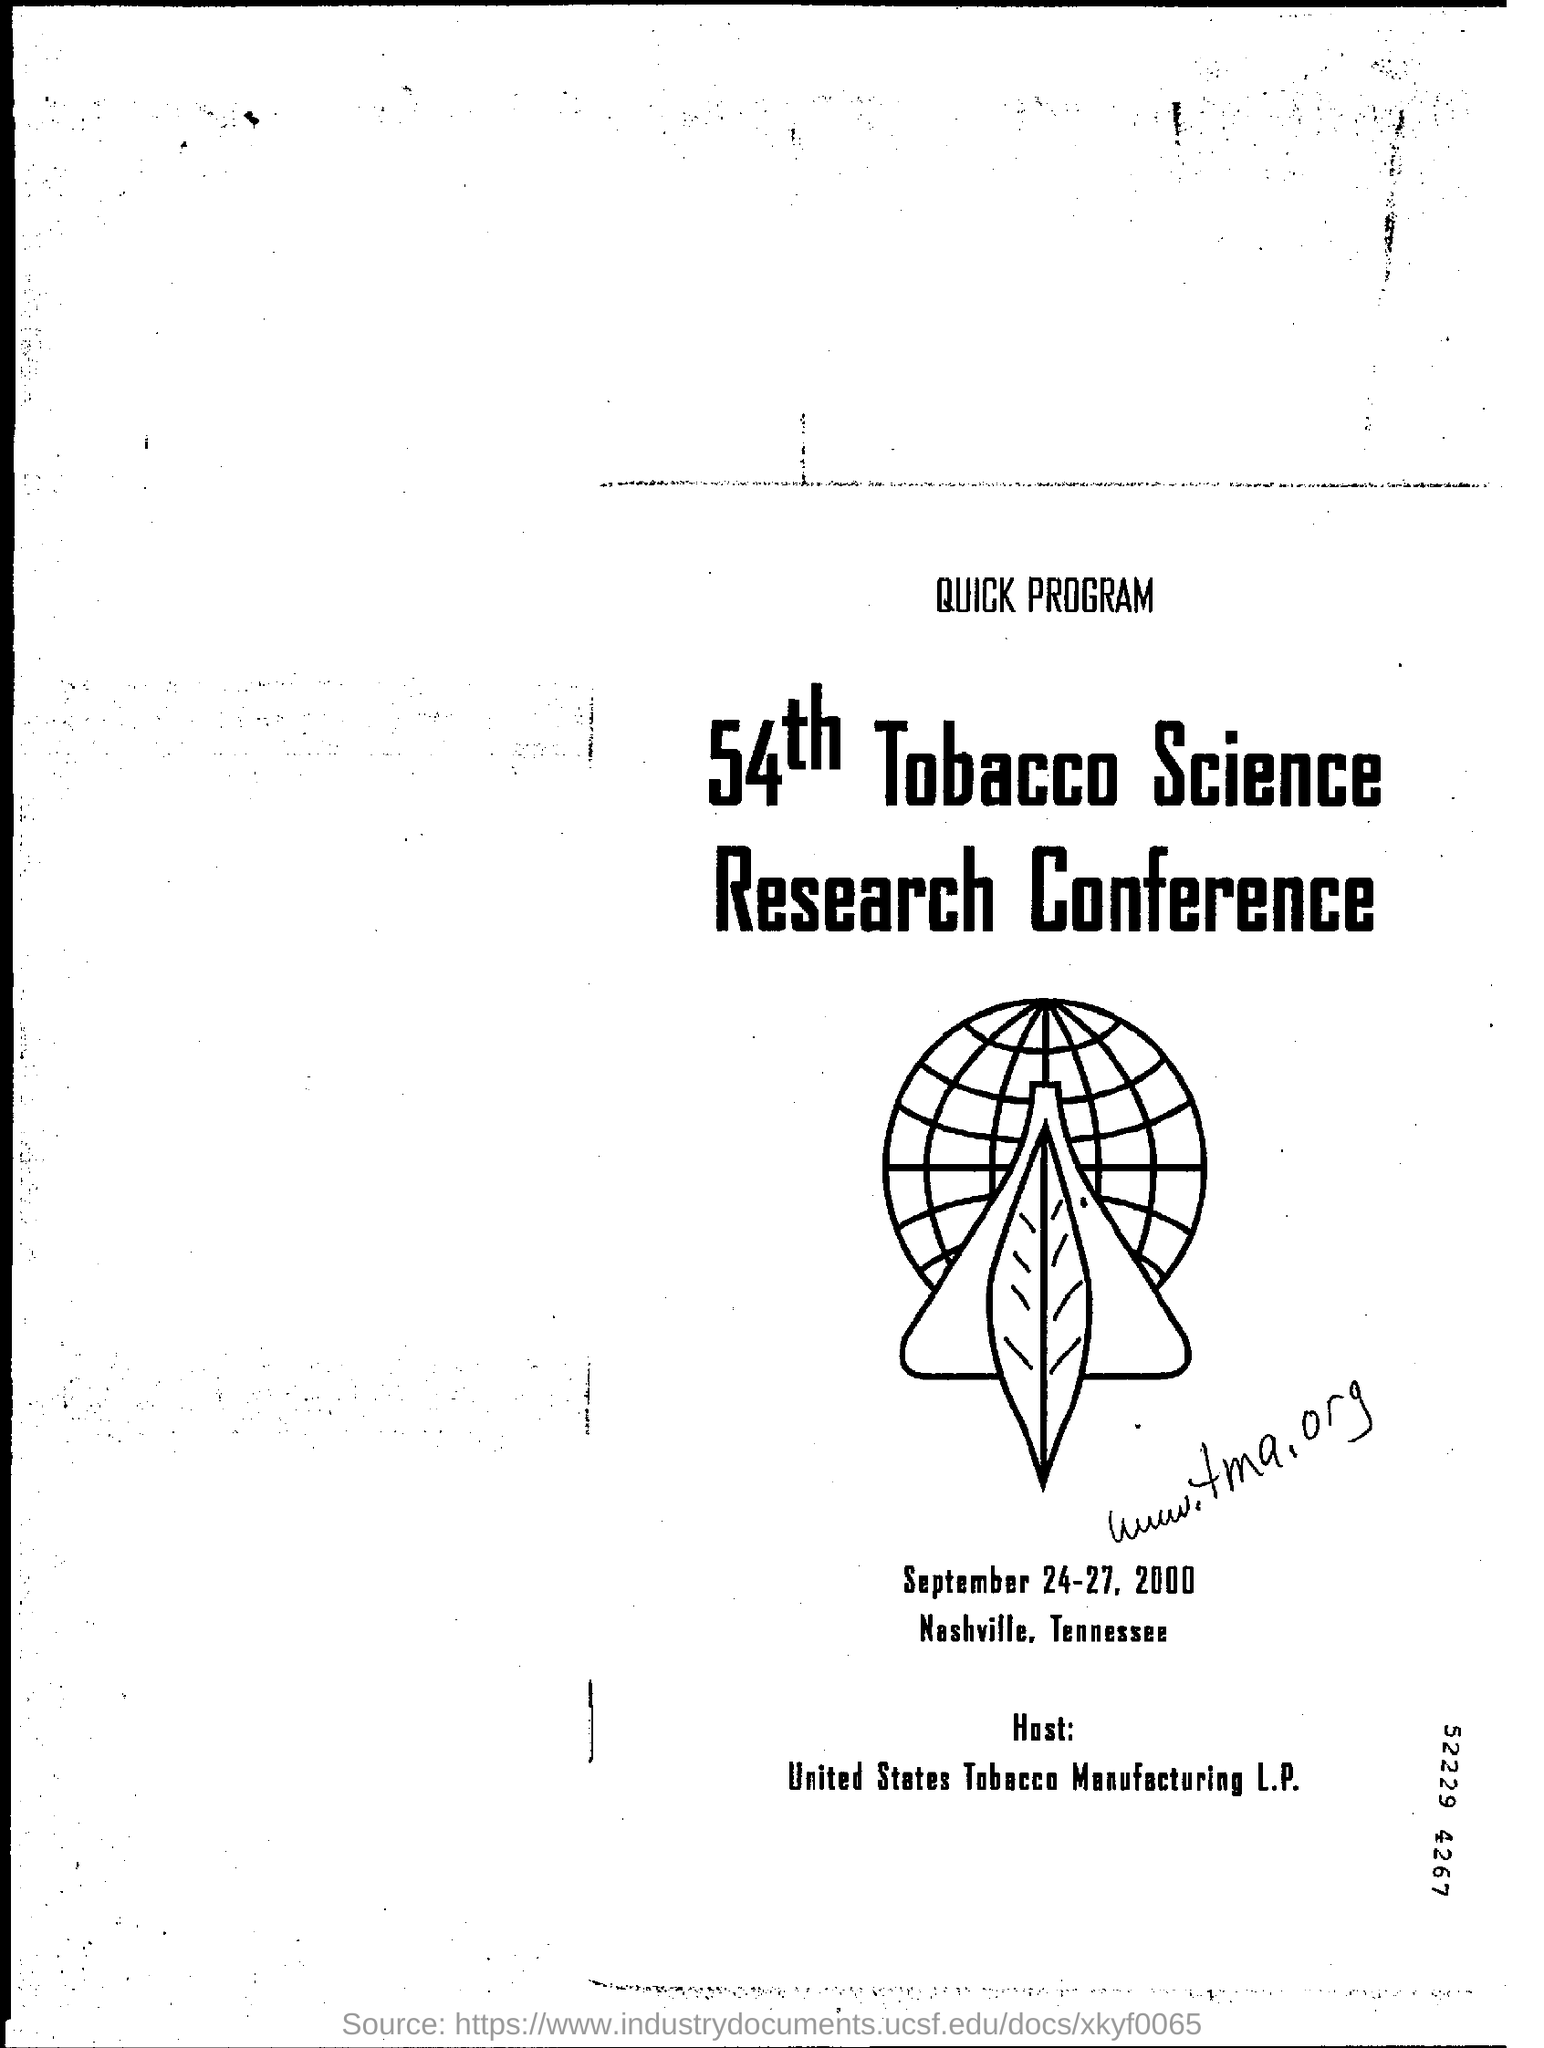Who is hosting the conference?
Ensure brevity in your answer.  United States tobacco manufacturing L.P. Where is the conference held?
Keep it short and to the point. Nashville, Tennessee. What is the name of the conference?
Your answer should be compact. 54th Tobacco science research conference. 